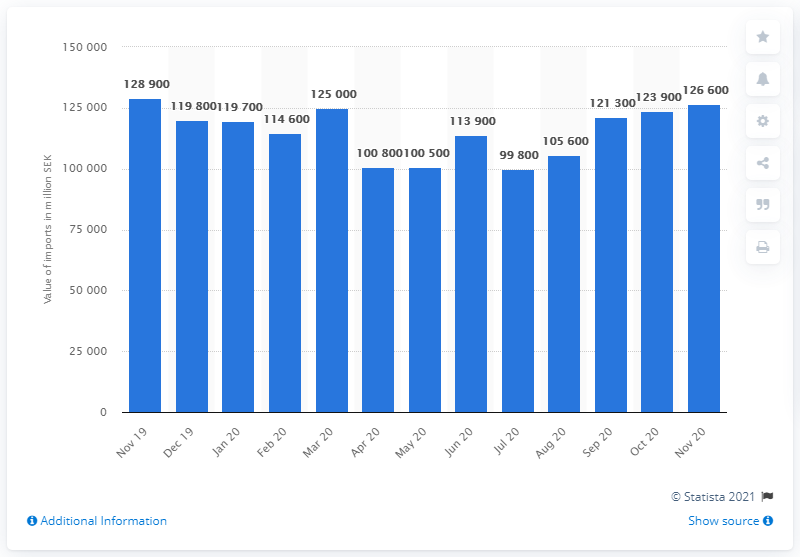Draw attention to some important aspects in this diagram. On July 1st, 2020, the lowest value of Swedish kronor was 9,9800. In November 2020, the value of imports reached 126,600 Swedish kronor. 